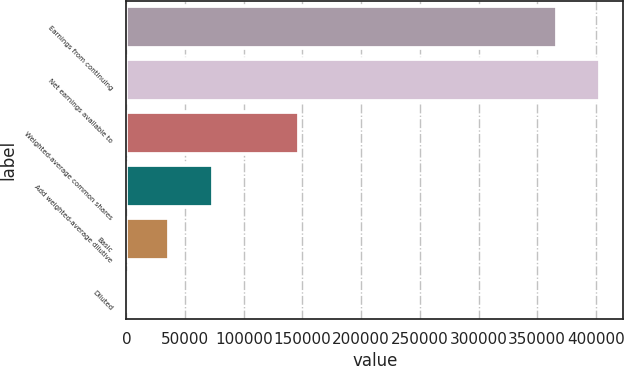Convert chart. <chart><loc_0><loc_0><loc_500><loc_500><bar_chart><fcel>Earnings from continuing<fcel>Net earnings available to<fcel>Weighted-average common shares<fcel>Add weighted-average dilutive<fcel>Basic<fcel>Diluted<nl><fcel>366681<fcel>403349<fcel>146675<fcel>73340.2<fcel>36672.7<fcel>5.07<nl></chart> 